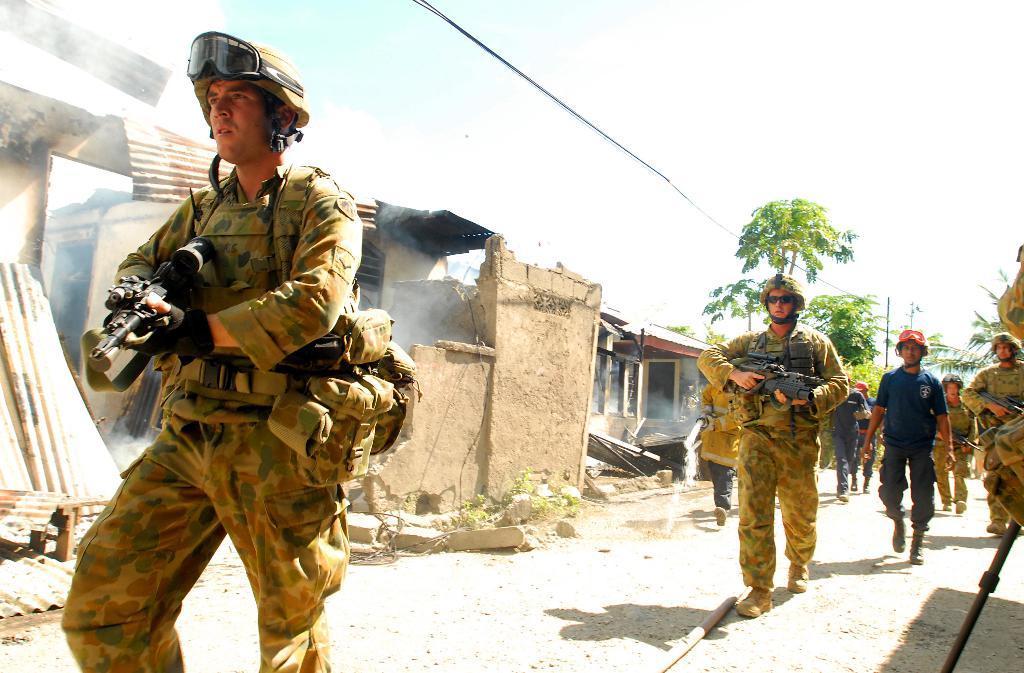Could you give a brief overview of what you see in this image? This is an outside view. Here I can see few people wearing uniforms, holding guns in their hands and walking on the ground. In the background there are few houses and trees. Beside the road there are few stones. At the top of the image I can see the sky. 